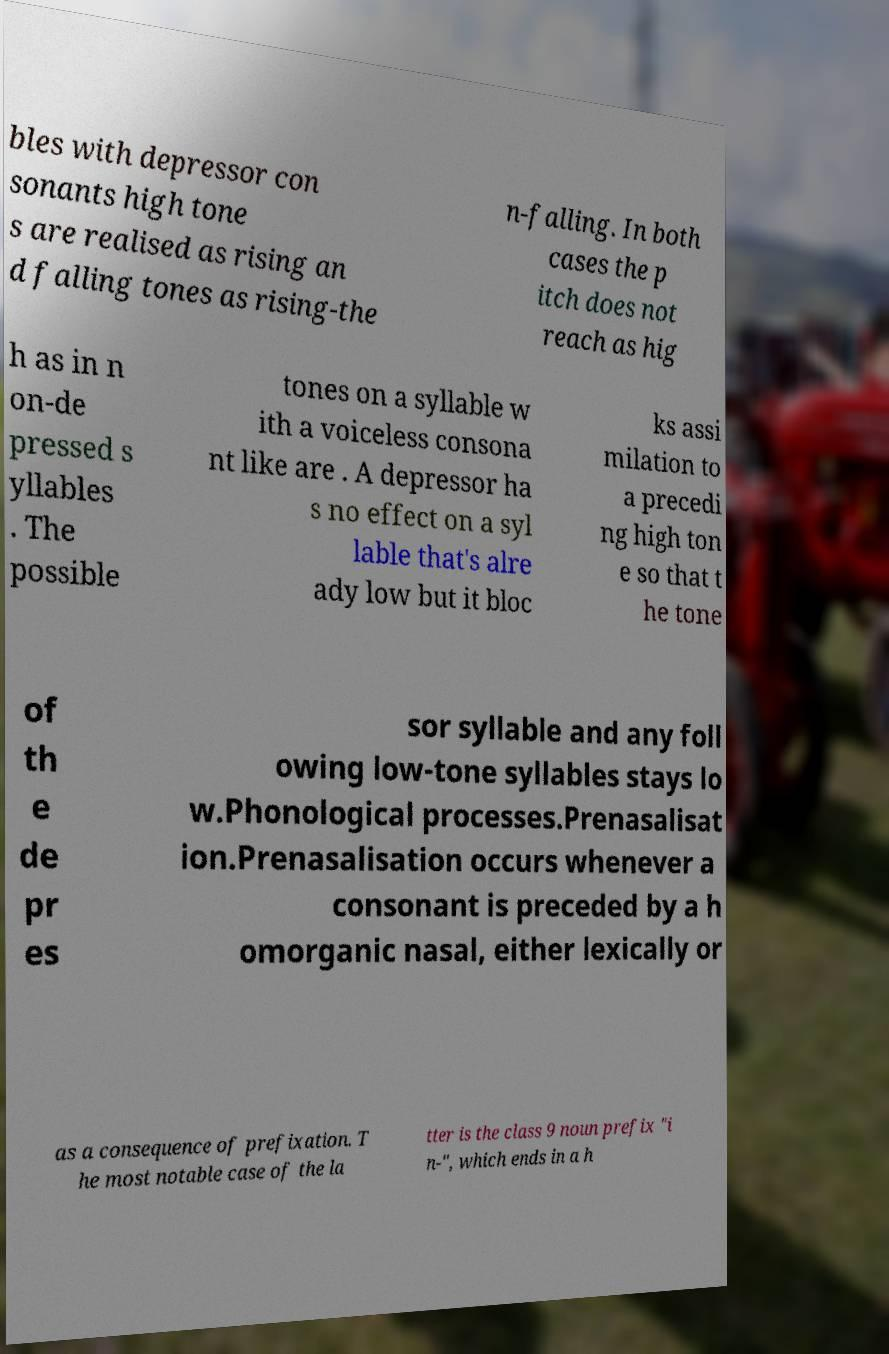Can you accurately transcribe the text from the provided image for me? bles with depressor con sonants high tone s are realised as rising an d falling tones as rising-the n-falling. In both cases the p itch does not reach as hig h as in n on-de pressed s yllables . The possible tones on a syllable w ith a voiceless consona nt like are . A depressor ha s no effect on a syl lable that's alre ady low but it bloc ks assi milation to a precedi ng high ton e so that t he tone of th e de pr es sor syllable and any foll owing low-tone syllables stays lo w.Phonological processes.Prenasalisat ion.Prenasalisation occurs whenever a consonant is preceded by a h omorganic nasal, either lexically or as a consequence of prefixation. T he most notable case of the la tter is the class 9 noun prefix "i n-", which ends in a h 